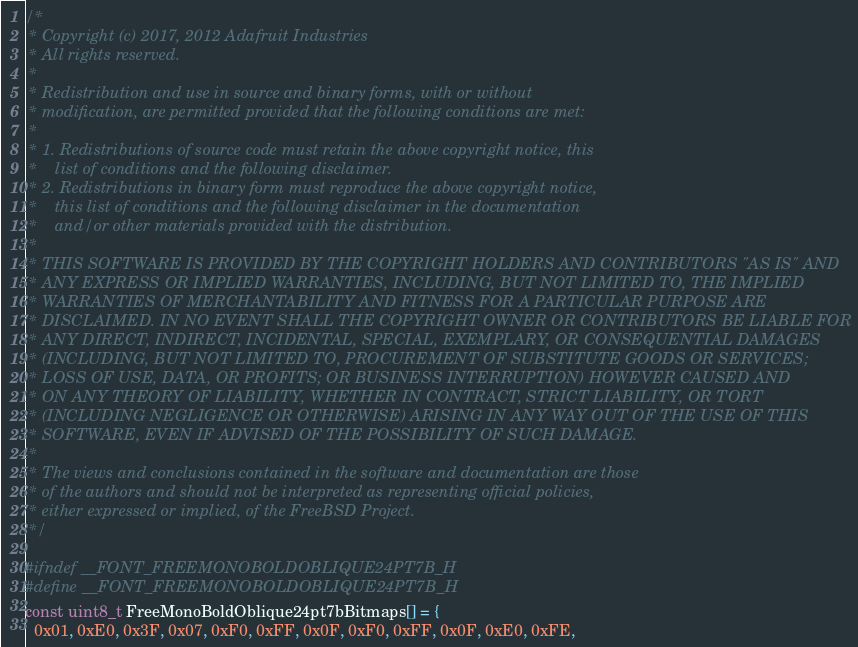Convert code to text. <code><loc_0><loc_0><loc_500><loc_500><_C_>/*
 * Copyright (c) 2017, 2012 Adafruit Industries
 * All rights reserved.
 *
 * Redistribution and use in source and binary forms, with or without
 * modification, are permitted provided that the following conditions are met:
 *
 * 1. Redistributions of source code must retain the above copyright notice, this
 *    list of conditions and the following disclaimer.
 * 2. Redistributions in binary form must reproduce the above copyright notice,
 *    this list of conditions and the following disclaimer in the documentation
 *    and/or other materials provided with the distribution.
 *
 * THIS SOFTWARE IS PROVIDED BY THE COPYRIGHT HOLDERS AND CONTRIBUTORS "AS IS" AND
 * ANY EXPRESS OR IMPLIED WARRANTIES, INCLUDING, BUT NOT LIMITED TO, THE IMPLIED
 * WARRANTIES OF MERCHANTABILITY AND FITNESS FOR A PARTICULAR PURPOSE ARE
 * DISCLAIMED. IN NO EVENT SHALL THE COPYRIGHT OWNER OR CONTRIBUTORS BE LIABLE FOR
 * ANY DIRECT, INDIRECT, INCIDENTAL, SPECIAL, EXEMPLARY, OR CONSEQUENTIAL DAMAGES
 * (INCLUDING, BUT NOT LIMITED TO, PROCUREMENT OF SUBSTITUTE GOODS OR SERVICES;
 * LOSS OF USE, DATA, OR PROFITS; OR BUSINESS INTERRUPTION) HOWEVER CAUSED AND
 * ON ANY THEORY OF LIABILITY, WHETHER IN CONTRACT, STRICT LIABILITY, OR TORT
 * (INCLUDING NEGLIGENCE OR OTHERWISE) ARISING IN ANY WAY OUT OF THE USE OF THIS
 * SOFTWARE, EVEN IF ADVISED OF THE POSSIBILITY OF SUCH DAMAGE.
 *
 * The views and conclusions contained in the software and documentation are those
 * of the authors and should not be interpreted as representing official policies,
 * either expressed or implied, of the FreeBSD Project.
 */

#ifndef __FONT_FREEMONOBOLDOBLIQUE24PT7B_H
#define __FONT_FREEMONOBOLDOBLIQUE24PT7B_H
const uint8_t FreeMonoBoldOblique24pt7bBitmaps[] = {
  0x01, 0xE0, 0x3F, 0x07, 0xF0, 0xFF, 0x0F, 0xF0, 0xFF, 0x0F, 0xE0, 0xFE,</code> 